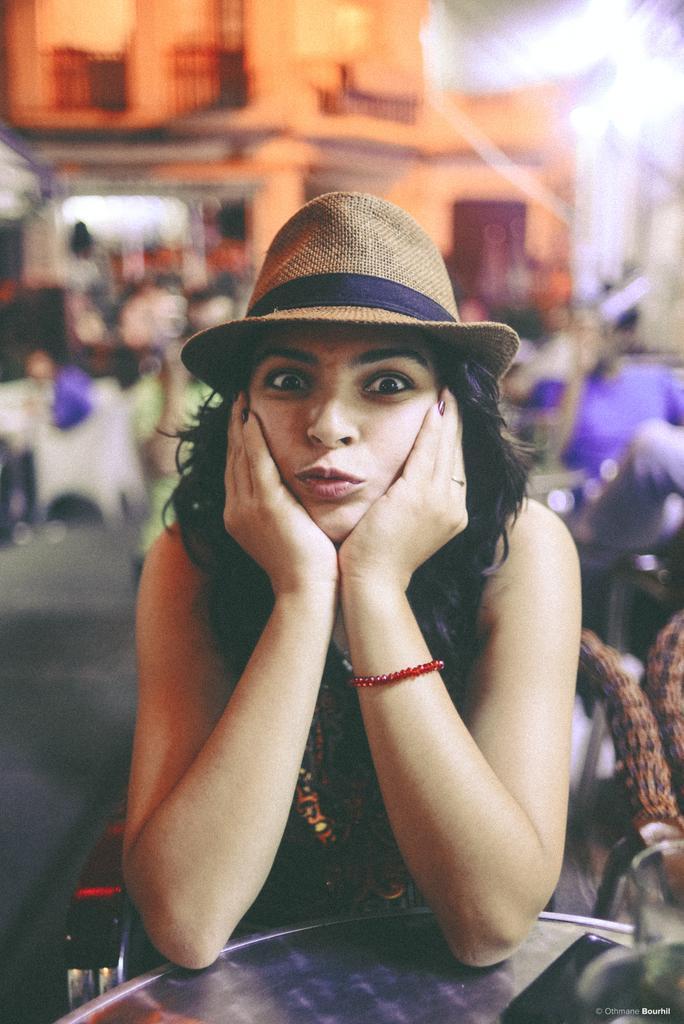In one or two sentences, can you explain what this image depicts? Here I can see a woman sitting on a chair in front of the table and giving pose for the picture. On the right side, I can see a chair. The background is blurred. 